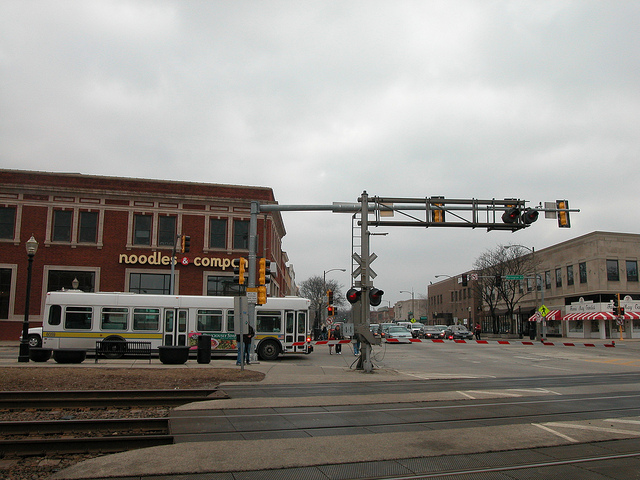Identify the text contained in this image. noodles compch 